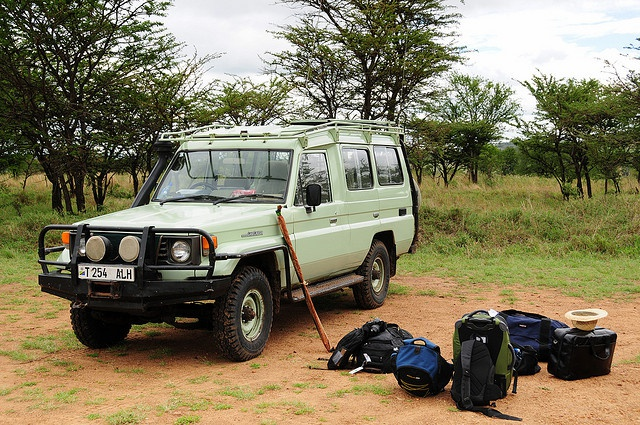Describe the objects in this image and their specific colors. I can see car in black, darkgray, ivory, and gray tones, backpack in black, darkgreen, and gray tones, backpack in black, navy, blue, and darkblue tones, suitcase in black, gray, darkgray, and maroon tones, and backpack in black, gray, darkgray, and white tones in this image. 